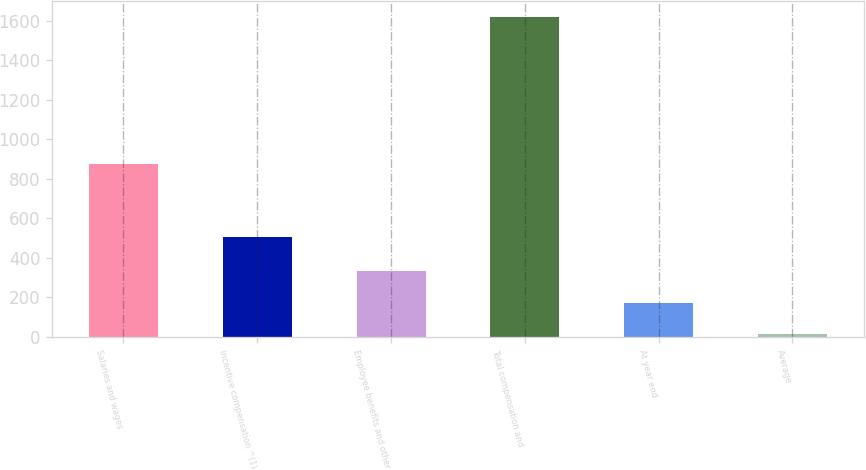Convert chart to OTSL. <chart><loc_0><loc_0><loc_500><loc_500><bar_chart><fcel>Salaries and wages<fcel>Incentive compensation ^(1)<fcel>Employee benefits and other<fcel>Total compensation and<fcel>At year end<fcel>Average<nl><fcel>872<fcel>504<fcel>333.32<fcel>1619<fcel>172.61<fcel>11.9<nl></chart> 